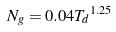Convert formula to latex. <formula><loc_0><loc_0><loc_500><loc_500>N _ { g } = 0 . 0 4 { T _ { d } } ^ { 1 . 2 5 }</formula> 